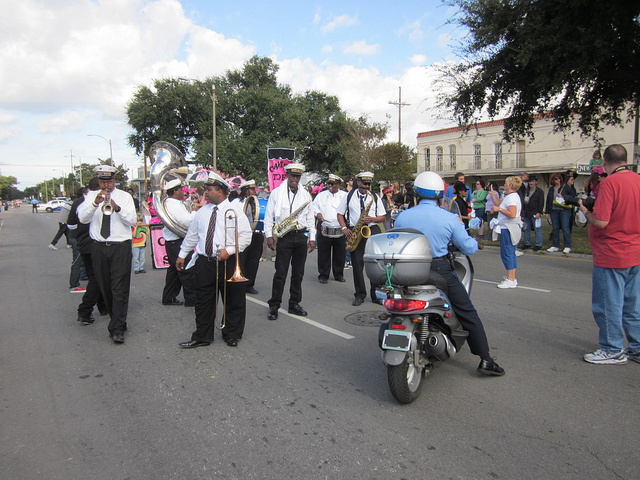Identify the text displayed in this image. C 9 